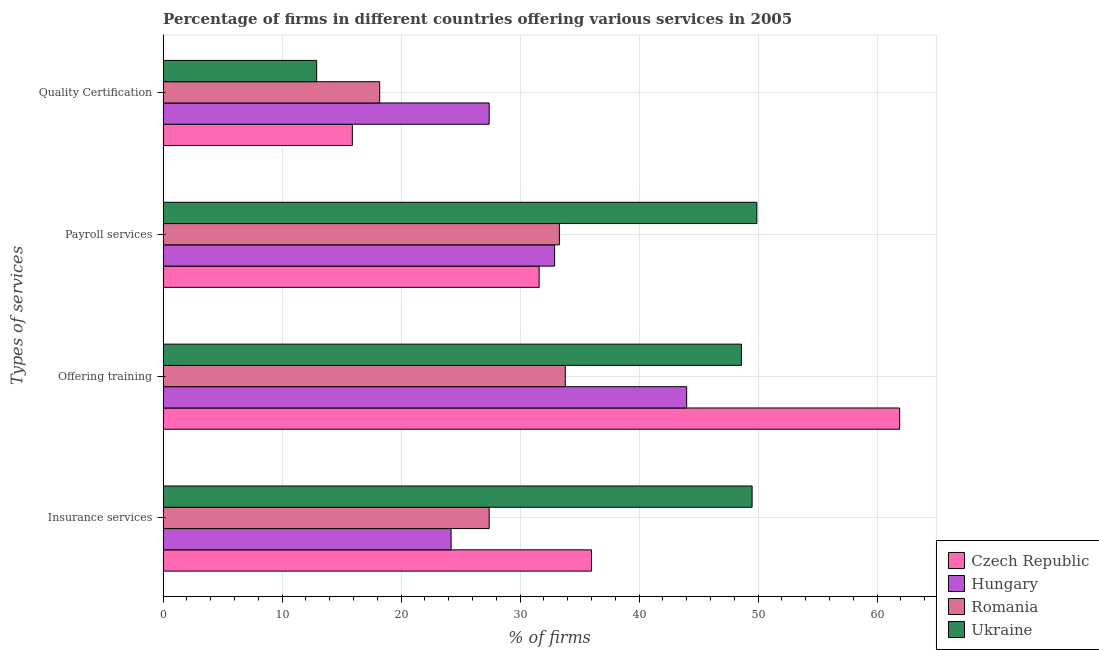How many different coloured bars are there?
Your response must be concise. 4. Are the number of bars on each tick of the Y-axis equal?
Your answer should be very brief. Yes. How many bars are there on the 3rd tick from the top?
Your response must be concise. 4. How many bars are there on the 2nd tick from the bottom?
Provide a short and direct response. 4. What is the label of the 4th group of bars from the top?
Your answer should be compact. Insurance services. What is the percentage of firms offering training in Ukraine?
Make the answer very short. 48.6. Across all countries, what is the maximum percentage of firms offering quality certification?
Your answer should be very brief. 27.4. Across all countries, what is the minimum percentage of firms offering payroll services?
Keep it short and to the point. 31.6. In which country was the percentage of firms offering insurance services maximum?
Your answer should be compact. Ukraine. In which country was the percentage of firms offering insurance services minimum?
Offer a very short reply. Hungary. What is the total percentage of firms offering quality certification in the graph?
Your answer should be compact. 74.4. What is the difference between the percentage of firms offering payroll services in Romania and that in Czech Republic?
Your answer should be compact. 1.7. What is the difference between the percentage of firms offering quality certification in Ukraine and the percentage of firms offering training in Czech Republic?
Provide a succinct answer. -49. What is the average percentage of firms offering insurance services per country?
Your response must be concise. 34.27. What is the difference between the percentage of firms offering quality certification and percentage of firms offering insurance services in Romania?
Ensure brevity in your answer.  -9.2. In how many countries, is the percentage of firms offering insurance services greater than 10 %?
Provide a short and direct response. 4. What is the ratio of the percentage of firms offering insurance services in Hungary to that in Romania?
Offer a terse response. 0.88. Is the percentage of firms offering payroll services in Romania less than that in Czech Republic?
Provide a succinct answer. No. What is the difference between the highest and the lowest percentage of firms offering insurance services?
Offer a very short reply. 25.3. In how many countries, is the percentage of firms offering training greater than the average percentage of firms offering training taken over all countries?
Provide a short and direct response. 2. What does the 4th bar from the top in Insurance services represents?
Your answer should be very brief. Czech Republic. What does the 4th bar from the bottom in Offering training represents?
Offer a very short reply. Ukraine. Is it the case that in every country, the sum of the percentage of firms offering insurance services and percentage of firms offering training is greater than the percentage of firms offering payroll services?
Make the answer very short. Yes. How many bars are there?
Give a very brief answer. 16. How many countries are there in the graph?
Your answer should be compact. 4. Does the graph contain any zero values?
Your response must be concise. No. Does the graph contain grids?
Offer a very short reply. Yes. Where does the legend appear in the graph?
Your answer should be very brief. Bottom right. How are the legend labels stacked?
Give a very brief answer. Vertical. What is the title of the graph?
Provide a succinct answer. Percentage of firms in different countries offering various services in 2005. Does "Central Europe" appear as one of the legend labels in the graph?
Keep it short and to the point. No. What is the label or title of the X-axis?
Offer a very short reply. % of firms. What is the label or title of the Y-axis?
Offer a very short reply. Types of services. What is the % of firms in Czech Republic in Insurance services?
Offer a very short reply. 36. What is the % of firms in Hungary in Insurance services?
Your answer should be very brief. 24.2. What is the % of firms of Romania in Insurance services?
Offer a very short reply. 27.4. What is the % of firms of Ukraine in Insurance services?
Offer a very short reply. 49.5. What is the % of firms of Czech Republic in Offering training?
Offer a terse response. 61.9. What is the % of firms of Hungary in Offering training?
Provide a succinct answer. 44. What is the % of firms of Romania in Offering training?
Your answer should be compact. 33.8. What is the % of firms of Ukraine in Offering training?
Your answer should be compact. 48.6. What is the % of firms of Czech Republic in Payroll services?
Provide a short and direct response. 31.6. What is the % of firms of Hungary in Payroll services?
Your answer should be compact. 32.9. What is the % of firms in Romania in Payroll services?
Make the answer very short. 33.3. What is the % of firms of Ukraine in Payroll services?
Offer a terse response. 49.9. What is the % of firms of Czech Republic in Quality Certification?
Offer a very short reply. 15.9. What is the % of firms in Hungary in Quality Certification?
Keep it short and to the point. 27.4. Across all Types of services, what is the maximum % of firms of Czech Republic?
Make the answer very short. 61.9. Across all Types of services, what is the maximum % of firms of Romania?
Make the answer very short. 33.8. Across all Types of services, what is the maximum % of firms in Ukraine?
Provide a succinct answer. 49.9. Across all Types of services, what is the minimum % of firms in Hungary?
Your answer should be very brief. 24.2. Across all Types of services, what is the minimum % of firms in Ukraine?
Offer a very short reply. 12.9. What is the total % of firms in Czech Republic in the graph?
Provide a succinct answer. 145.4. What is the total % of firms of Hungary in the graph?
Offer a very short reply. 128.5. What is the total % of firms of Romania in the graph?
Give a very brief answer. 112.7. What is the total % of firms in Ukraine in the graph?
Offer a terse response. 160.9. What is the difference between the % of firms in Czech Republic in Insurance services and that in Offering training?
Offer a very short reply. -25.9. What is the difference between the % of firms of Hungary in Insurance services and that in Offering training?
Your answer should be very brief. -19.8. What is the difference between the % of firms in Czech Republic in Insurance services and that in Payroll services?
Provide a succinct answer. 4.4. What is the difference between the % of firms in Hungary in Insurance services and that in Payroll services?
Ensure brevity in your answer.  -8.7. What is the difference between the % of firms of Czech Republic in Insurance services and that in Quality Certification?
Your response must be concise. 20.1. What is the difference between the % of firms in Hungary in Insurance services and that in Quality Certification?
Offer a very short reply. -3.2. What is the difference between the % of firms in Romania in Insurance services and that in Quality Certification?
Your answer should be compact. 9.2. What is the difference between the % of firms in Ukraine in Insurance services and that in Quality Certification?
Offer a very short reply. 36.6. What is the difference between the % of firms in Czech Republic in Offering training and that in Payroll services?
Provide a short and direct response. 30.3. What is the difference between the % of firms in Romania in Offering training and that in Payroll services?
Your answer should be compact. 0.5. What is the difference between the % of firms in Hungary in Offering training and that in Quality Certification?
Provide a succinct answer. 16.6. What is the difference between the % of firms of Ukraine in Offering training and that in Quality Certification?
Offer a terse response. 35.7. What is the difference between the % of firms of Czech Republic in Payroll services and that in Quality Certification?
Keep it short and to the point. 15.7. What is the difference between the % of firms in Hungary in Payroll services and that in Quality Certification?
Offer a very short reply. 5.5. What is the difference between the % of firms of Hungary in Insurance services and the % of firms of Romania in Offering training?
Ensure brevity in your answer.  -9.6. What is the difference between the % of firms in Hungary in Insurance services and the % of firms in Ukraine in Offering training?
Offer a terse response. -24.4. What is the difference between the % of firms of Romania in Insurance services and the % of firms of Ukraine in Offering training?
Make the answer very short. -21.2. What is the difference between the % of firms in Czech Republic in Insurance services and the % of firms in Ukraine in Payroll services?
Make the answer very short. -13.9. What is the difference between the % of firms of Hungary in Insurance services and the % of firms of Romania in Payroll services?
Provide a succinct answer. -9.1. What is the difference between the % of firms of Hungary in Insurance services and the % of firms of Ukraine in Payroll services?
Your answer should be compact. -25.7. What is the difference between the % of firms of Romania in Insurance services and the % of firms of Ukraine in Payroll services?
Keep it short and to the point. -22.5. What is the difference between the % of firms of Czech Republic in Insurance services and the % of firms of Hungary in Quality Certification?
Keep it short and to the point. 8.6. What is the difference between the % of firms in Czech Republic in Insurance services and the % of firms in Romania in Quality Certification?
Ensure brevity in your answer.  17.8. What is the difference between the % of firms in Czech Republic in Insurance services and the % of firms in Ukraine in Quality Certification?
Provide a short and direct response. 23.1. What is the difference between the % of firms of Hungary in Insurance services and the % of firms of Ukraine in Quality Certification?
Your response must be concise. 11.3. What is the difference between the % of firms in Czech Republic in Offering training and the % of firms in Romania in Payroll services?
Make the answer very short. 28.6. What is the difference between the % of firms in Czech Republic in Offering training and the % of firms in Ukraine in Payroll services?
Your response must be concise. 12. What is the difference between the % of firms in Hungary in Offering training and the % of firms in Ukraine in Payroll services?
Ensure brevity in your answer.  -5.9. What is the difference between the % of firms of Romania in Offering training and the % of firms of Ukraine in Payroll services?
Offer a very short reply. -16.1. What is the difference between the % of firms in Czech Republic in Offering training and the % of firms in Hungary in Quality Certification?
Provide a short and direct response. 34.5. What is the difference between the % of firms of Czech Republic in Offering training and the % of firms of Romania in Quality Certification?
Your answer should be very brief. 43.7. What is the difference between the % of firms of Hungary in Offering training and the % of firms of Romania in Quality Certification?
Your answer should be very brief. 25.8. What is the difference between the % of firms in Hungary in Offering training and the % of firms in Ukraine in Quality Certification?
Your response must be concise. 31.1. What is the difference between the % of firms in Romania in Offering training and the % of firms in Ukraine in Quality Certification?
Your answer should be very brief. 20.9. What is the difference between the % of firms in Czech Republic in Payroll services and the % of firms in Hungary in Quality Certification?
Offer a terse response. 4.2. What is the difference between the % of firms of Czech Republic in Payroll services and the % of firms of Romania in Quality Certification?
Keep it short and to the point. 13.4. What is the difference between the % of firms of Hungary in Payroll services and the % of firms of Ukraine in Quality Certification?
Your answer should be compact. 20. What is the difference between the % of firms of Romania in Payroll services and the % of firms of Ukraine in Quality Certification?
Provide a succinct answer. 20.4. What is the average % of firms in Czech Republic per Types of services?
Your answer should be compact. 36.35. What is the average % of firms in Hungary per Types of services?
Offer a terse response. 32.12. What is the average % of firms of Romania per Types of services?
Keep it short and to the point. 28.18. What is the average % of firms of Ukraine per Types of services?
Ensure brevity in your answer.  40.23. What is the difference between the % of firms in Hungary and % of firms in Romania in Insurance services?
Your response must be concise. -3.2. What is the difference between the % of firms in Hungary and % of firms in Ukraine in Insurance services?
Your answer should be very brief. -25.3. What is the difference between the % of firms of Romania and % of firms of Ukraine in Insurance services?
Your answer should be very brief. -22.1. What is the difference between the % of firms in Czech Republic and % of firms in Romania in Offering training?
Keep it short and to the point. 28.1. What is the difference between the % of firms of Czech Republic and % of firms of Ukraine in Offering training?
Provide a succinct answer. 13.3. What is the difference between the % of firms in Hungary and % of firms in Romania in Offering training?
Provide a succinct answer. 10.2. What is the difference between the % of firms in Hungary and % of firms in Ukraine in Offering training?
Give a very brief answer. -4.6. What is the difference between the % of firms in Romania and % of firms in Ukraine in Offering training?
Give a very brief answer. -14.8. What is the difference between the % of firms of Czech Republic and % of firms of Romania in Payroll services?
Keep it short and to the point. -1.7. What is the difference between the % of firms in Czech Republic and % of firms in Ukraine in Payroll services?
Your answer should be compact. -18.3. What is the difference between the % of firms of Hungary and % of firms of Ukraine in Payroll services?
Make the answer very short. -17. What is the difference between the % of firms of Romania and % of firms of Ukraine in Payroll services?
Your answer should be compact. -16.6. What is the difference between the % of firms in Czech Republic and % of firms in Romania in Quality Certification?
Ensure brevity in your answer.  -2.3. What is the difference between the % of firms of Czech Republic and % of firms of Ukraine in Quality Certification?
Make the answer very short. 3. What is the difference between the % of firms in Hungary and % of firms in Romania in Quality Certification?
Give a very brief answer. 9.2. What is the difference between the % of firms in Romania and % of firms in Ukraine in Quality Certification?
Give a very brief answer. 5.3. What is the ratio of the % of firms of Czech Republic in Insurance services to that in Offering training?
Keep it short and to the point. 0.58. What is the ratio of the % of firms in Hungary in Insurance services to that in Offering training?
Offer a terse response. 0.55. What is the ratio of the % of firms of Romania in Insurance services to that in Offering training?
Give a very brief answer. 0.81. What is the ratio of the % of firms of Ukraine in Insurance services to that in Offering training?
Offer a terse response. 1.02. What is the ratio of the % of firms of Czech Republic in Insurance services to that in Payroll services?
Offer a terse response. 1.14. What is the ratio of the % of firms of Hungary in Insurance services to that in Payroll services?
Your answer should be very brief. 0.74. What is the ratio of the % of firms of Romania in Insurance services to that in Payroll services?
Offer a terse response. 0.82. What is the ratio of the % of firms in Ukraine in Insurance services to that in Payroll services?
Offer a terse response. 0.99. What is the ratio of the % of firms in Czech Republic in Insurance services to that in Quality Certification?
Provide a short and direct response. 2.26. What is the ratio of the % of firms in Hungary in Insurance services to that in Quality Certification?
Your response must be concise. 0.88. What is the ratio of the % of firms of Romania in Insurance services to that in Quality Certification?
Provide a succinct answer. 1.51. What is the ratio of the % of firms in Ukraine in Insurance services to that in Quality Certification?
Your response must be concise. 3.84. What is the ratio of the % of firms in Czech Republic in Offering training to that in Payroll services?
Give a very brief answer. 1.96. What is the ratio of the % of firms of Hungary in Offering training to that in Payroll services?
Offer a terse response. 1.34. What is the ratio of the % of firms in Romania in Offering training to that in Payroll services?
Make the answer very short. 1.01. What is the ratio of the % of firms of Ukraine in Offering training to that in Payroll services?
Provide a succinct answer. 0.97. What is the ratio of the % of firms of Czech Republic in Offering training to that in Quality Certification?
Your response must be concise. 3.89. What is the ratio of the % of firms of Hungary in Offering training to that in Quality Certification?
Provide a succinct answer. 1.61. What is the ratio of the % of firms of Romania in Offering training to that in Quality Certification?
Make the answer very short. 1.86. What is the ratio of the % of firms in Ukraine in Offering training to that in Quality Certification?
Ensure brevity in your answer.  3.77. What is the ratio of the % of firms in Czech Republic in Payroll services to that in Quality Certification?
Your answer should be compact. 1.99. What is the ratio of the % of firms in Hungary in Payroll services to that in Quality Certification?
Give a very brief answer. 1.2. What is the ratio of the % of firms of Romania in Payroll services to that in Quality Certification?
Ensure brevity in your answer.  1.83. What is the ratio of the % of firms of Ukraine in Payroll services to that in Quality Certification?
Ensure brevity in your answer.  3.87. What is the difference between the highest and the second highest % of firms in Czech Republic?
Your response must be concise. 25.9. What is the difference between the highest and the second highest % of firms of Romania?
Keep it short and to the point. 0.5. What is the difference between the highest and the second highest % of firms in Ukraine?
Provide a short and direct response. 0.4. What is the difference between the highest and the lowest % of firms in Czech Republic?
Give a very brief answer. 46. What is the difference between the highest and the lowest % of firms of Hungary?
Keep it short and to the point. 19.8. 